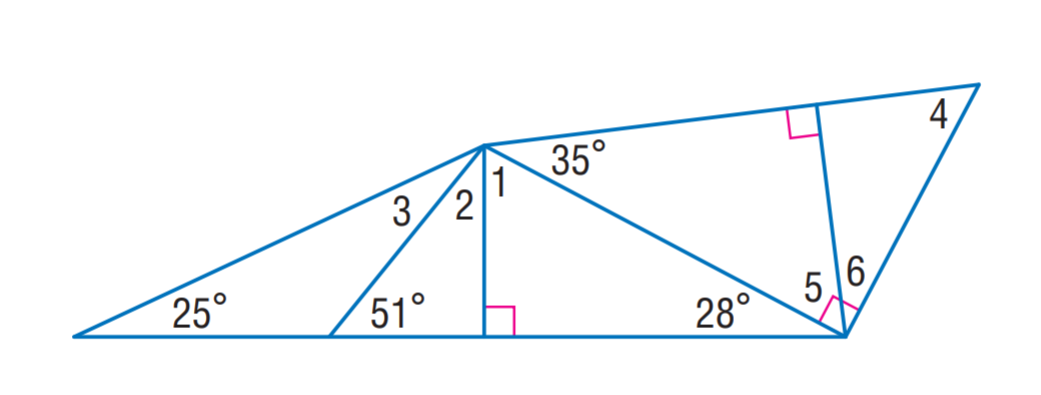Answer the mathemtical geometry problem and directly provide the correct option letter.
Question: Find m \angle 1.
Choices: A: 39 B: 55 C: 62 D: 83 C 